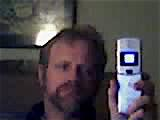Question: what is the man holding?
Choices:
A. A beverage.
B. A wallet.
C. A cell phone.
D. A tablet.
Answer with the letter. Answer: C 